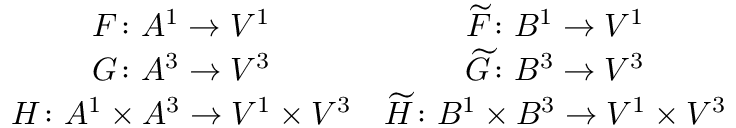Convert formula to latex. <formula><loc_0><loc_0><loc_500><loc_500>\begin{array} { c c } { F \colon A ^ { 1 } \to V ^ { 1 } } & { \widetilde { F } \colon B ^ { 1 } \to V ^ { 1 } } \\ { G \colon A ^ { 3 } \to V ^ { 3 } } & { \widetilde { G } \colon B ^ { 3 } \to V ^ { 3 } } \\ { H \colon A ^ { 1 } \times A ^ { 3 } \to V ^ { 1 } \times V ^ { 3 } } & { \widetilde { H } \colon B ^ { 1 } \times B ^ { 3 } \to V ^ { 1 } \times V ^ { 3 } } \end{array}</formula> 